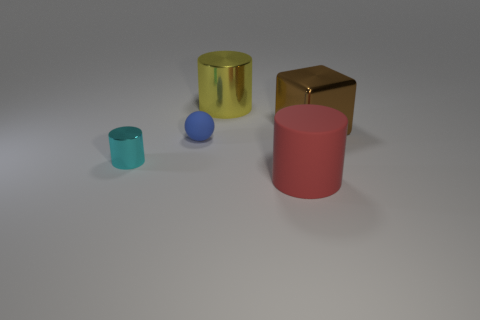Add 1 small yellow matte cubes. How many objects exist? 6 Subtract all blocks. How many objects are left? 4 Subtract all tiny red rubber cylinders. Subtract all small blue rubber spheres. How many objects are left? 4 Add 3 large yellow cylinders. How many large yellow cylinders are left? 4 Add 2 big gray metal things. How many big gray metal things exist? 2 Subtract 0 green cylinders. How many objects are left? 5 